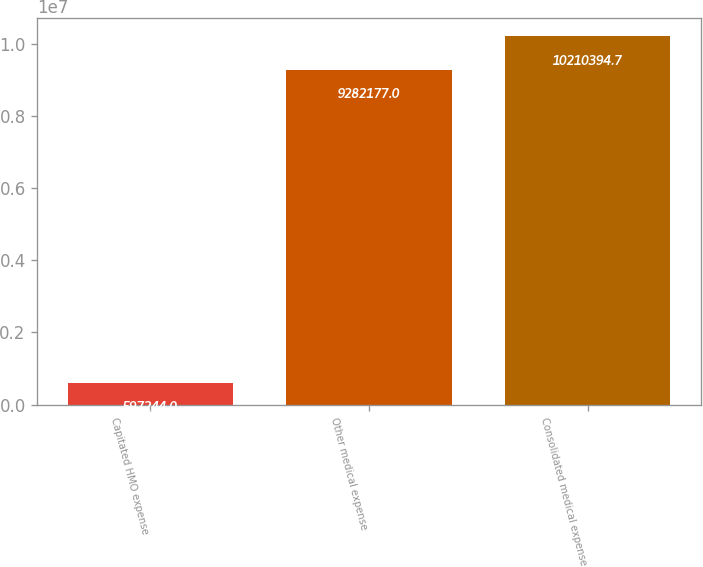Convert chart to OTSL. <chart><loc_0><loc_0><loc_500><loc_500><bar_chart><fcel>Capitated HMO expense<fcel>Other medical expense<fcel>Consolidated medical expense<nl><fcel>597244<fcel>9.28218e+06<fcel>1.02104e+07<nl></chart> 